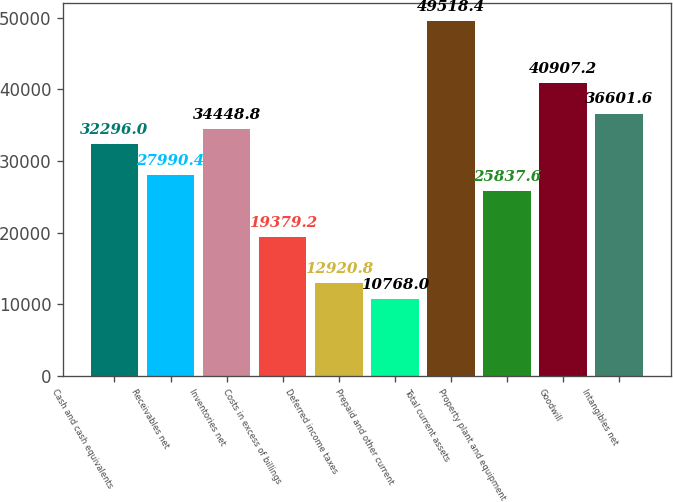Convert chart. <chart><loc_0><loc_0><loc_500><loc_500><bar_chart><fcel>Cash and cash equivalents<fcel>Receivables net<fcel>Inventories net<fcel>Costs in excess of billings<fcel>Deferred income taxes<fcel>Prepaid and other current<fcel>Total current assets<fcel>Property plant and equipment<fcel>Goodwill<fcel>Intangibles net<nl><fcel>32296<fcel>27990.4<fcel>34448.8<fcel>19379.2<fcel>12920.8<fcel>10768<fcel>49518.4<fcel>25837.6<fcel>40907.2<fcel>36601.6<nl></chart> 